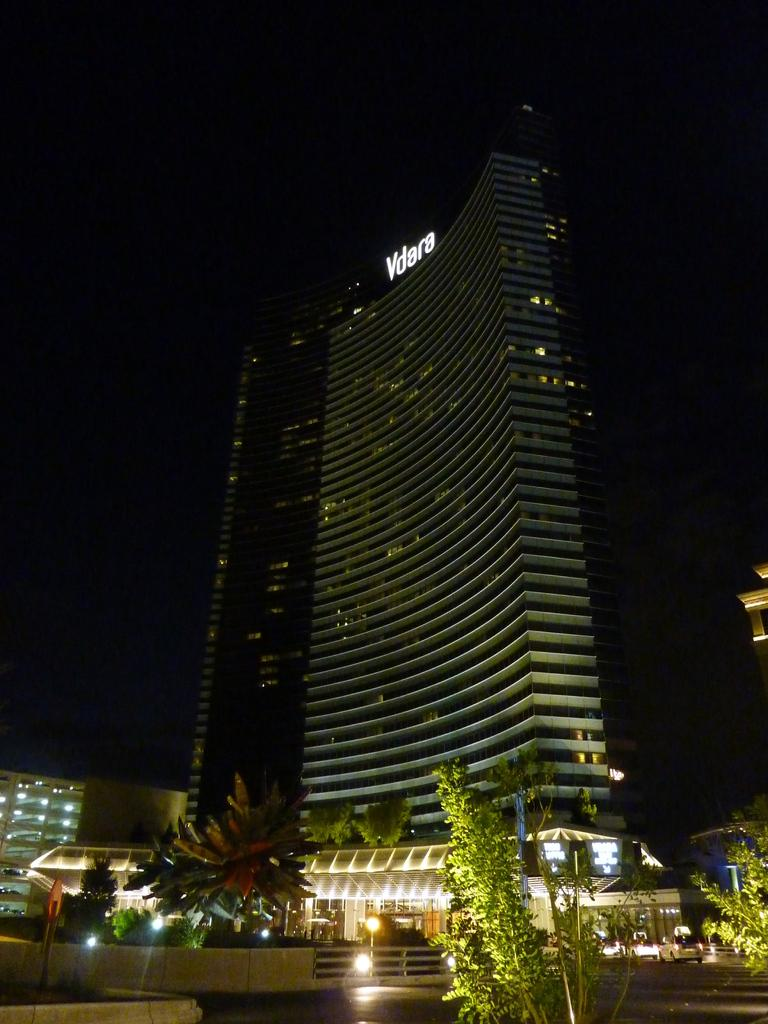What is located in the foreground of the image? In the foreground of the image, there is a pole, trees, a fence, lights, vehicles, and buildings. Can you describe the vegetation in the foreground of the image? There are trees in the foreground of the image. What type of man-made structure can be seen in the foreground of the image? There is a fence in the foreground of the image. What is the source of illumination in the foreground of the image? There are lights in the foreground of the image. What type of transportation is visible in the foreground of the image? There are vehicles on the road in the foreground of the image. What type of structures can be seen in the foreground of the image? There are buildings in the foreground of the image. What can be seen in the background of the image? The sky is visible in the background of the image. What time of day is the image taken? The image is taken during night. What type of cup is being used to rub the son's back in the image? There is no cup or son present in the image. What type of material is the son's shirt made of in the image? There is no son present in the image, so it is not possible to determine the material of his shirt. 